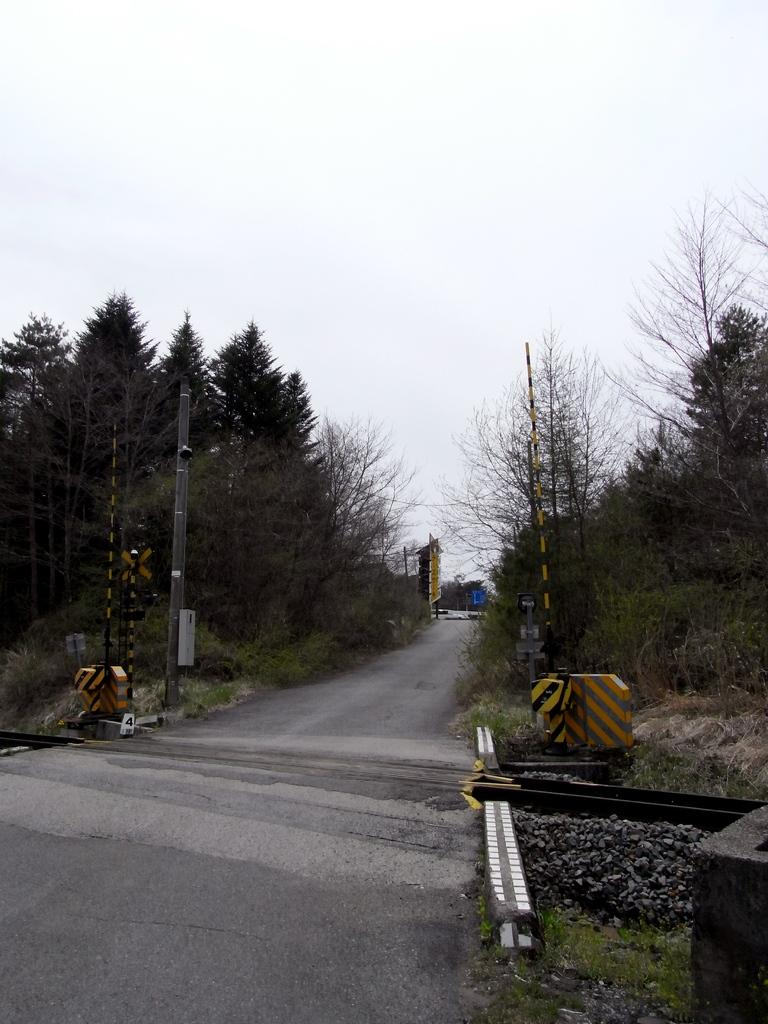What type of vegetation can be seen in the image? There is a group of trees in the image. What structures are present in the image? There are poles and a board in the image. What type of surface is visible in the image? There is a pathway and stones present in the image. What type of ground cover is visible? Grass is visible in the image. What part of the natural environment is visible in the image? The sky is visible in the image. Can you see any ornaments hanging from the trees in the image? There are no ornaments hanging from the trees in the image. Are there any bikes visible on the pathway in the image? There are no bikes visible on the pathway in the image. 